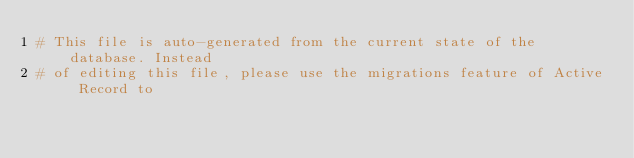Convert code to text. <code><loc_0><loc_0><loc_500><loc_500><_Ruby_># This file is auto-generated from the current state of the database. Instead
# of editing this file, please use the migrations feature of Active Record to</code> 